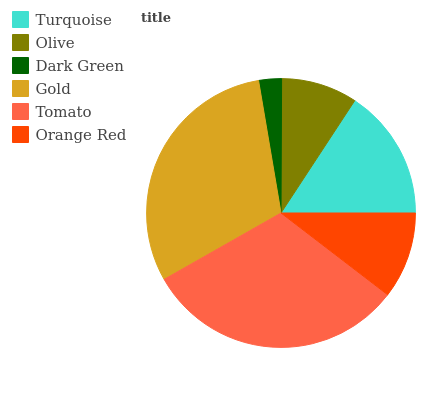Is Dark Green the minimum?
Answer yes or no. Yes. Is Tomato the maximum?
Answer yes or no. Yes. Is Olive the minimum?
Answer yes or no. No. Is Olive the maximum?
Answer yes or no. No. Is Turquoise greater than Olive?
Answer yes or no. Yes. Is Olive less than Turquoise?
Answer yes or no. Yes. Is Olive greater than Turquoise?
Answer yes or no. No. Is Turquoise less than Olive?
Answer yes or no. No. Is Turquoise the high median?
Answer yes or no. Yes. Is Orange Red the low median?
Answer yes or no. Yes. Is Olive the high median?
Answer yes or no. No. Is Dark Green the low median?
Answer yes or no. No. 